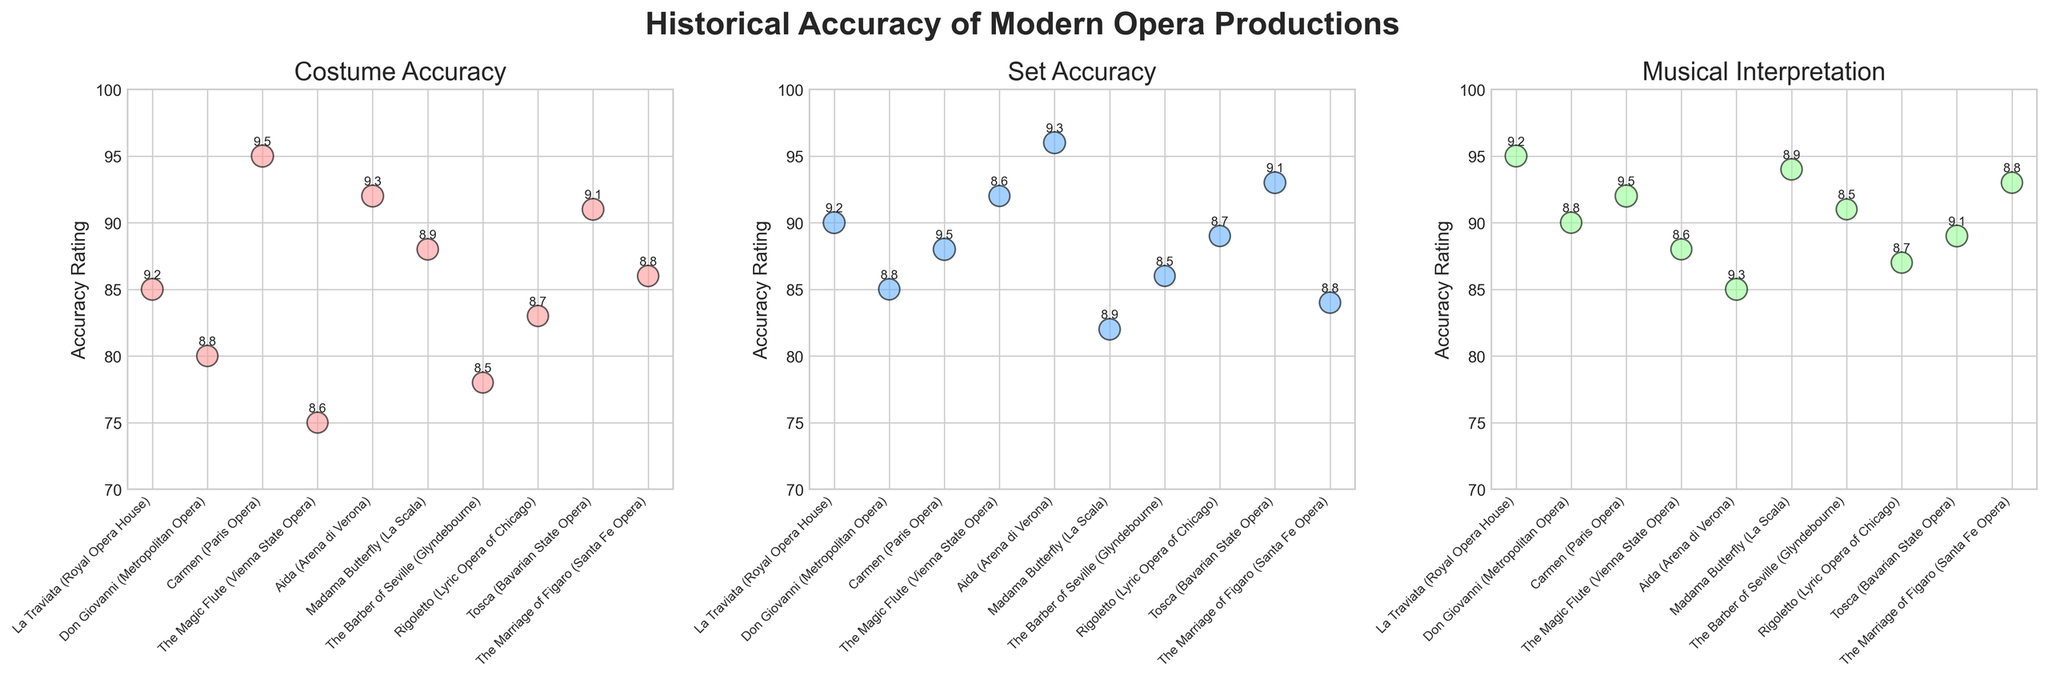What is the highest Costume Accuracy rating shown in the figure, and which opera does it belong to? The highest Costume Accuracy rating can be identified by looking at the plot for "Costume Accuracy" and finding the data point with the highest position on the y-axis. According to the plot, the highest rating is 95, which belongs to "Carmen (Paris Opera)".
Answer: 95, Carmen (Paris Opera) Which opera has the smallest bubble in the "Set Accuracy" plot, and what is its Overall Rating? The smallest bubble corresponds to the smallest Overall Rating as the size of the bubbles is determined by the Overall Rating. By observing the "Set Accuracy" plot, the smallest bubble is for "The Barber of Seville (Glyndebourne)" with an Overall Rating of 8.5.
Answer: The Barber of Seville (Glyndebourne), 8.5 How does the Costume Accuracy of "Madama Butterfly (La Scala)" compare to its Set Accuracy? To compare the two accuracy ratings, locate "Madama Butterfly (La Scala)" in both the "Costume Accuracy" and "Set Accuracy" plots. The Costume Accuracy is 88 and the Set Accuracy is 82. So, the Costume Accuracy is higher.
Answer: Costume Accuracy is higher What is the average Overall Rating of the operas in the "Musical Interpretation" plot? To find the average Overall Rating, sum up the Overall Ratings indicated on the "Musical Interpretation" plot and divide by the number of operas. The sum of the ratings is 9.2 + 8.8 + 9.5 + 8.6 + 9.3 + 8.9 + 8.5 + 8.7 + 9.1 + 8.8 = 88.4. There are 10 operas, so the average rating is 88.4 / 10 = 8.84.
Answer: 8.84 Which opera has the highest rating in the "Musical Interpretation" plot, and what is this rating? Look at the "Musical Interpretation" plot and identify the data point with the highest position on the y-axis. The highest rating is 95, which belongs to "La Traviata (Royal Opera House)".
Answer: 95, La Traviata (Royal Opera House) Between "The Magic Flute (Vienna State Opera)" and "Aida (Arena di Verona)", which has higher Set Accuracy, and by how much? To compare the Set Accuracy of these two operas, locate their data points in the "Set Accuracy" plot. "The Magic Flute (Vienna State Opera)" has a Set Accuracy of 92, while "Aida (Arena di Verona)" has 96. The difference is 96 - 92 = 4.
Answer: Aida is higher by 4 Are there any operas that have higher Musical Interpretation than Costume Accuracy? To answer this, check each opera's rating in both the "Musical Interpretation" and "Costume Accuracy" plots. Operas with higher Musical Interpretation than Costume Accuracy are "La Traviata (95 vs. 85)", "Don Giovanni (90 vs. 80)", "The Barber of Seville (91 vs. 78)", and "The Marriage of Figaro (93 vs. 86)".
Answer: Yes, 4 operas Which opera has the overall highest Set Accuracy rating, and what is this rating? Identify the highest point on the y-axis in the "Set Accuracy" plot. The highest Set Accuracy rating is 96, which belongs to "Aida (Arena di Verona)".
Answer: Aida (Arena di Verona), 96 